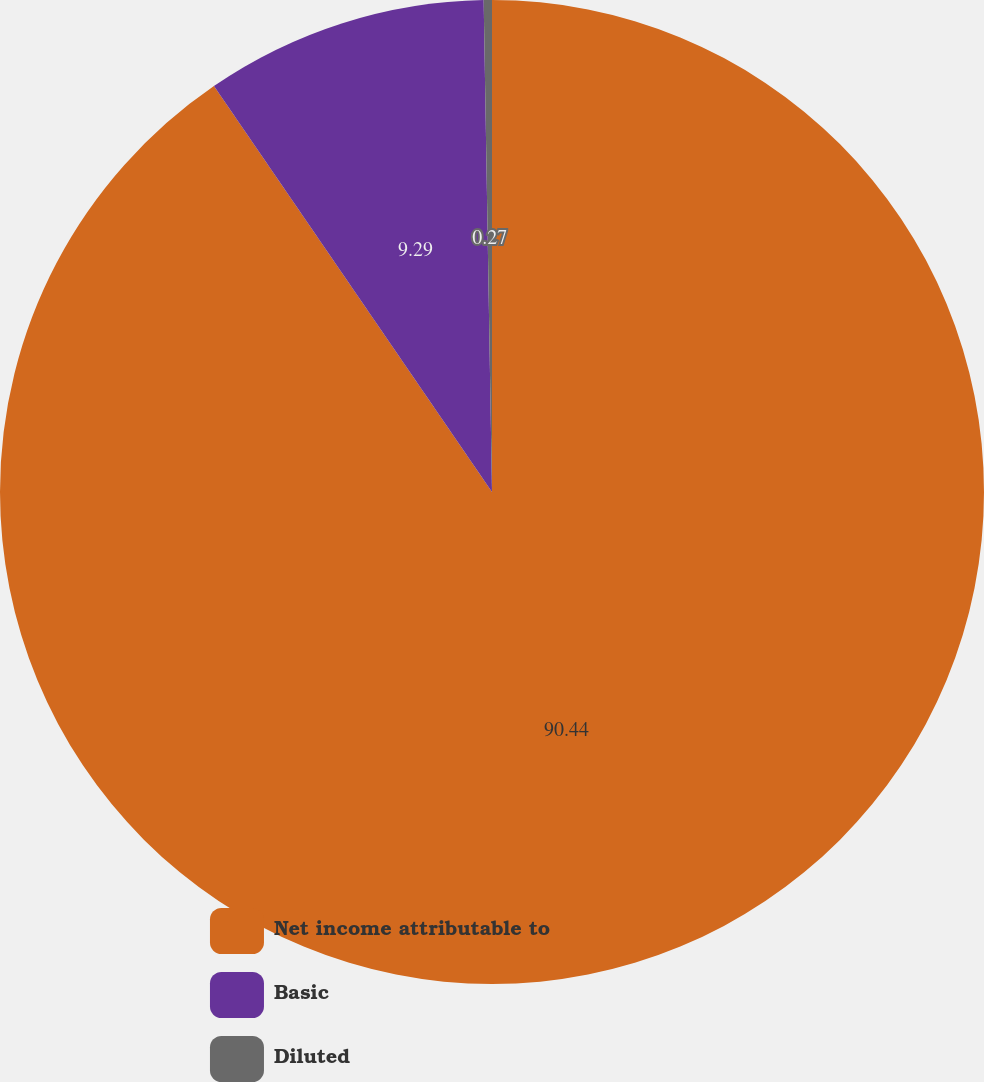<chart> <loc_0><loc_0><loc_500><loc_500><pie_chart><fcel>Net income attributable to<fcel>Basic<fcel>Diluted<nl><fcel>90.44%<fcel>9.29%<fcel>0.27%<nl></chart> 